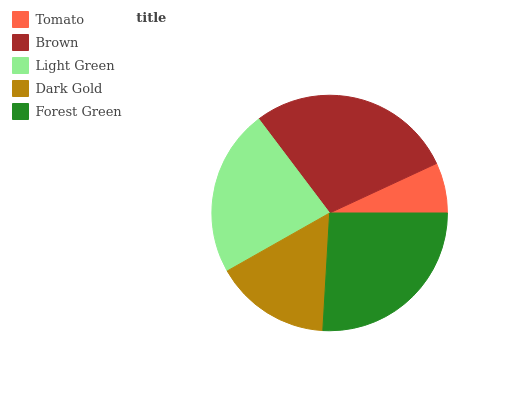Is Tomato the minimum?
Answer yes or no. Yes. Is Brown the maximum?
Answer yes or no. Yes. Is Light Green the minimum?
Answer yes or no. No. Is Light Green the maximum?
Answer yes or no. No. Is Brown greater than Light Green?
Answer yes or no. Yes. Is Light Green less than Brown?
Answer yes or no. Yes. Is Light Green greater than Brown?
Answer yes or no. No. Is Brown less than Light Green?
Answer yes or no. No. Is Light Green the high median?
Answer yes or no. Yes. Is Light Green the low median?
Answer yes or no. Yes. Is Forest Green the high median?
Answer yes or no. No. Is Brown the low median?
Answer yes or no. No. 